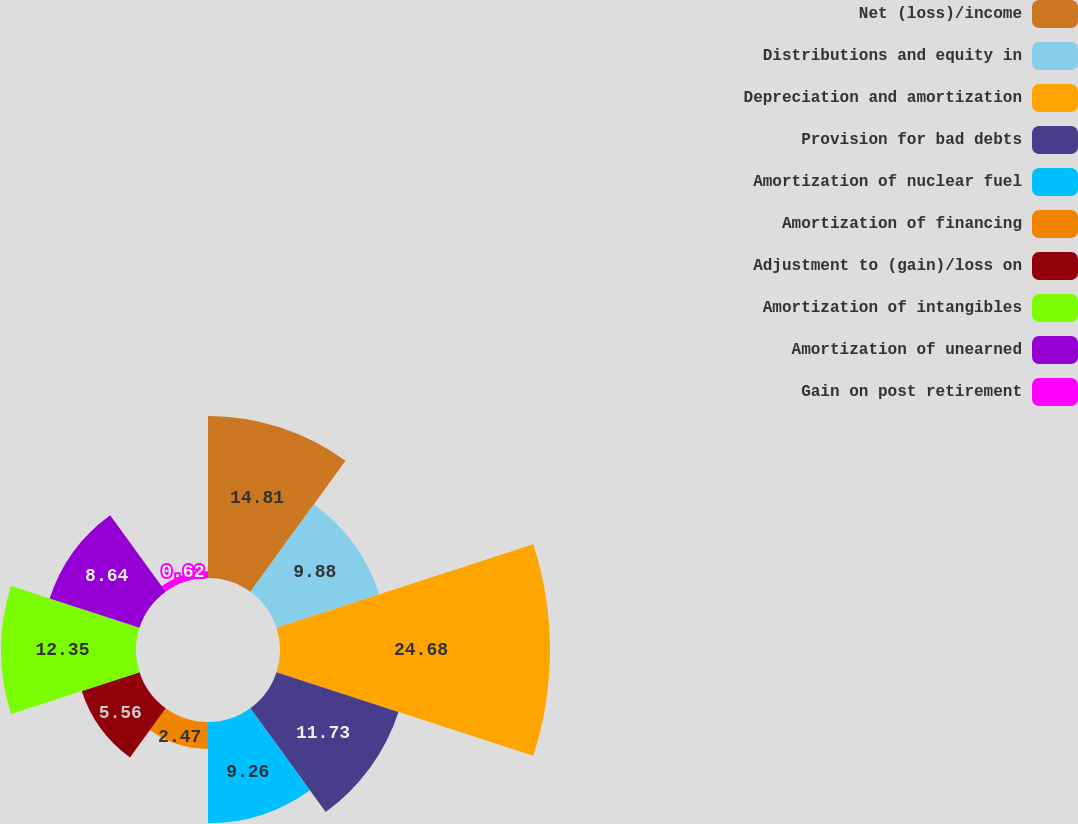Convert chart. <chart><loc_0><loc_0><loc_500><loc_500><pie_chart><fcel>Net (loss)/income<fcel>Distributions and equity in<fcel>Depreciation and amortization<fcel>Provision for bad debts<fcel>Amortization of nuclear fuel<fcel>Amortization of financing<fcel>Adjustment to (gain)/loss on<fcel>Amortization of intangibles<fcel>Amortization of unearned<fcel>Gain on post retirement<nl><fcel>14.81%<fcel>9.88%<fcel>24.69%<fcel>11.73%<fcel>9.26%<fcel>2.47%<fcel>5.56%<fcel>12.35%<fcel>8.64%<fcel>0.62%<nl></chart> 